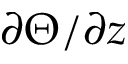Convert formula to latex. <formula><loc_0><loc_0><loc_500><loc_500>\partial \Theta / \partial z</formula> 